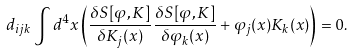<formula> <loc_0><loc_0><loc_500><loc_500>d _ { i j k } \int d ^ { 4 } x \left ( \frac { \delta S [ \varphi , K ] } { \delta K _ { j } ( x ) } \frac { \delta S [ \varphi , K ] } { \delta \varphi _ { k } ( x ) } + \varphi _ { j } ( x ) K _ { k } ( x ) \right ) = 0 .</formula> 